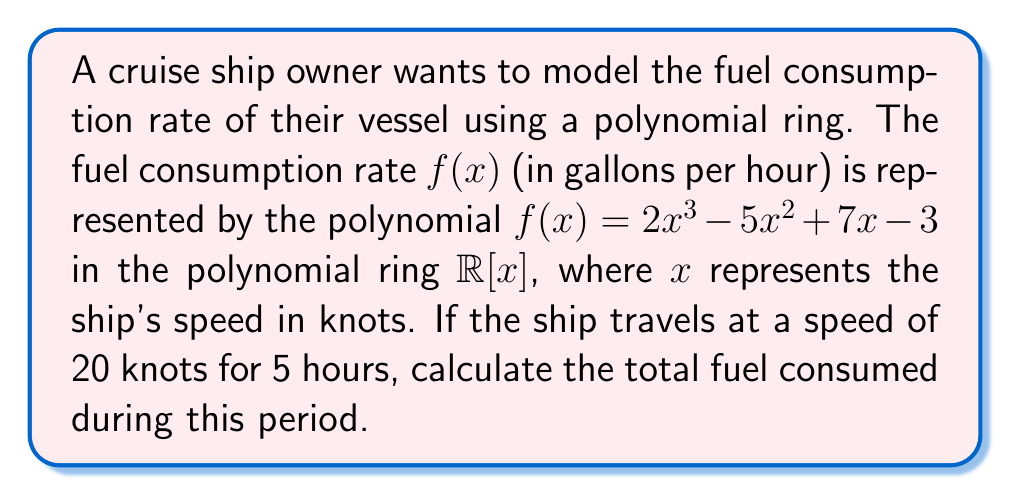Show me your answer to this math problem. To solve this problem, we'll follow these steps:

1) First, we need to evaluate the polynomial $f(x)$ at $x = 20$ to find the fuel consumption rate at 20 knots:

   $f(20) = 2(20^3) - 5(20^2) + 7(20) - 3$
   
   $= 2(8000) - 5(400) + 7(20) - 3$
   
   $= 16000 - 2000 + 140 - 3$
   
   $= 14137$ gallons per hour

2) Now that we know the fuel consumption rate, we can calculate the total fuel consumed over 5 hours:

   Total fuel = Fuel consumption rate × Time
   
   $= 14137 \times 5$
   
   $= 70685$ gallons

3) In the context of polynomial rings, this calculation can be interpreted as follows:
   
   We're working in the polynomial ring $\mathbb{R}[x]$, which consists of all polynomials with real coefficients.
   
   The evaluation of $f(20)$ is equivalent to computing $f(x)$ modulo $(x - 20)$ in $\mathbb{R}[x]$.
   
   The multiplication by 5 can be seen as scalar multiplication in the ring.

Therefore, the total fuel consumed over 5 hours at 20 knots is 70685 gallons.
Answer: 70685 gallons 